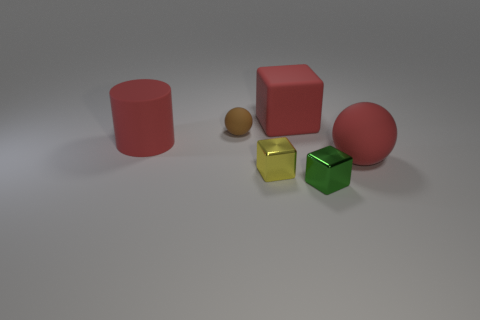Add 1 yellow shiny blocks. How many objects exist? 7 Subtract all balls. How many objects are left? 4 Add 5 shiny blocks. How many shiny blocks are left? 7 Add 1 tiny yellow objects. How many tiny yellow objects exist? 2 Subtract 1 brown balls. How many objects are left? 5 Subtract all things. Subtract all large green rubber cylinders. How many objects are left? 0 